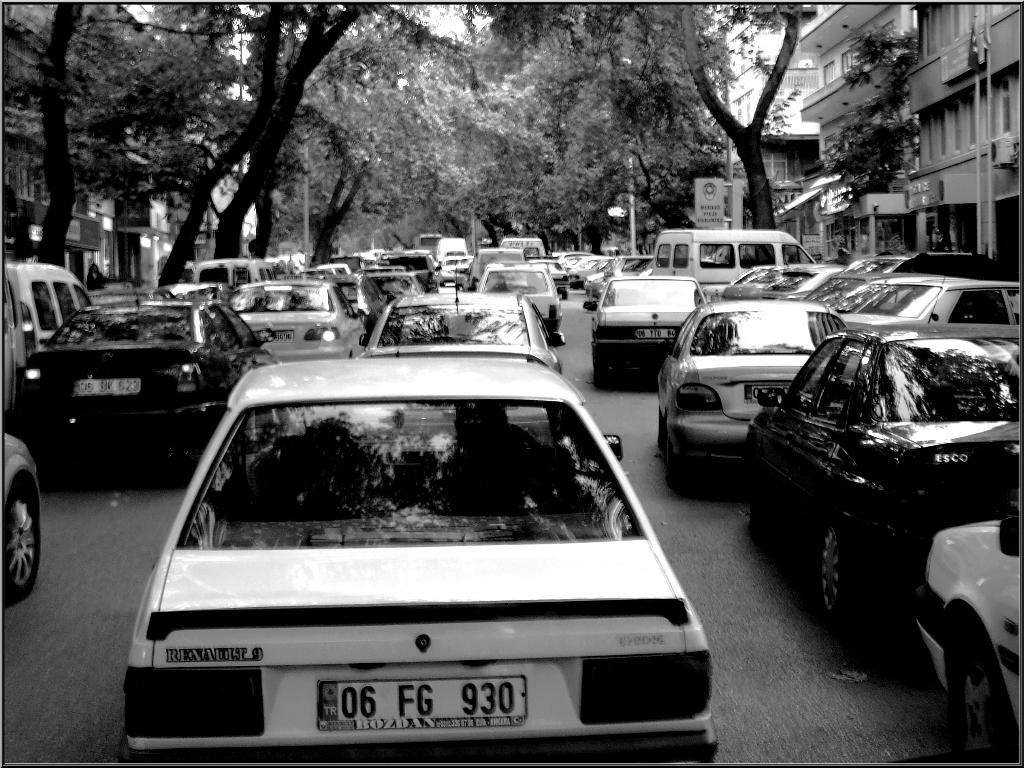What is the main subject of the image? The main subject of the image is many cars. What can be seen in the background of the image? There are buildings, trees, and posters in the background of the image. What type of disease is being treated in the image? There is no indication of a disease or any medical treatment in the image. Can you see a squirrel climbing one of the trees in the image? There is no squirrel present in the image. 